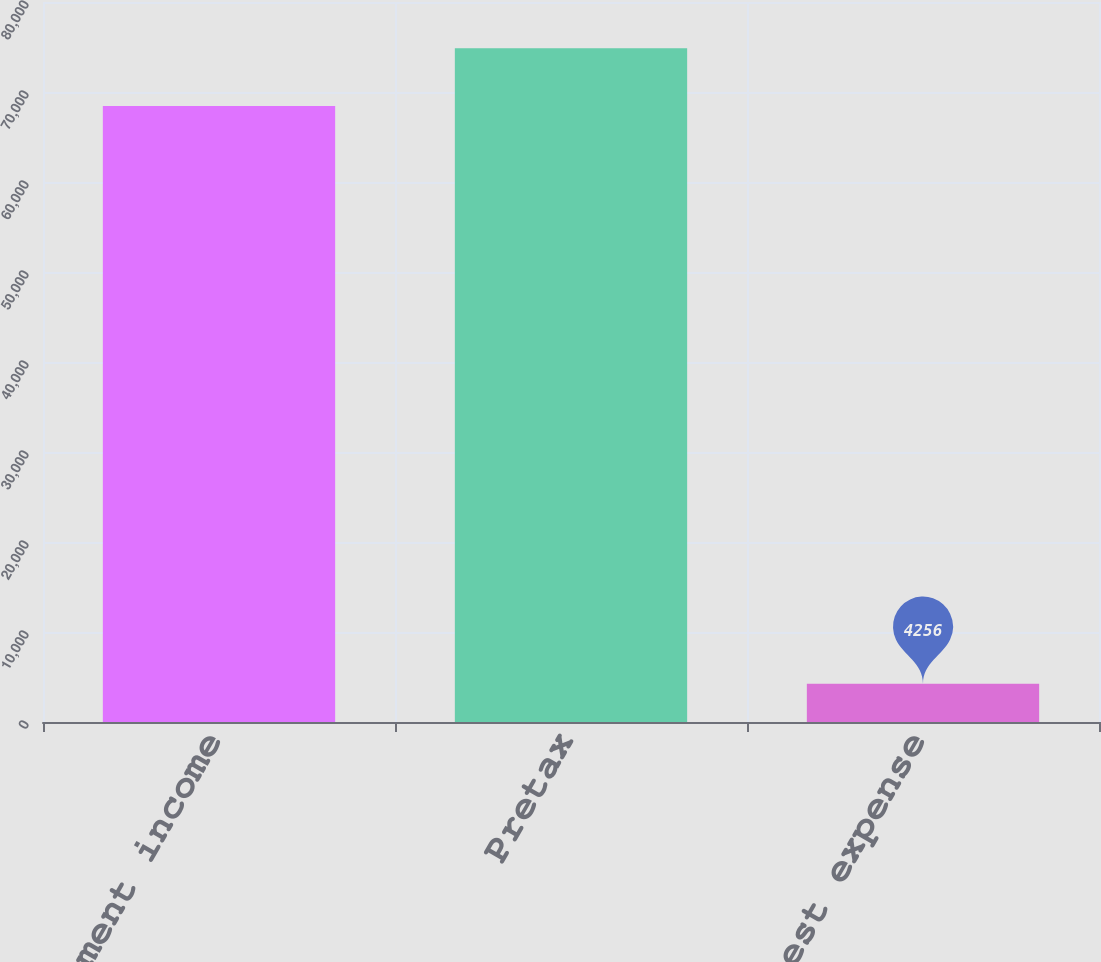<chart> <loc_0><loc_0><loc_500><loc_500><bar_chart><fcel>Investment income<fcel>Pretax<fcel>Interest expense<nl><fcel>68447<fcel>74866.1<fcel>4256<nl></chart> 